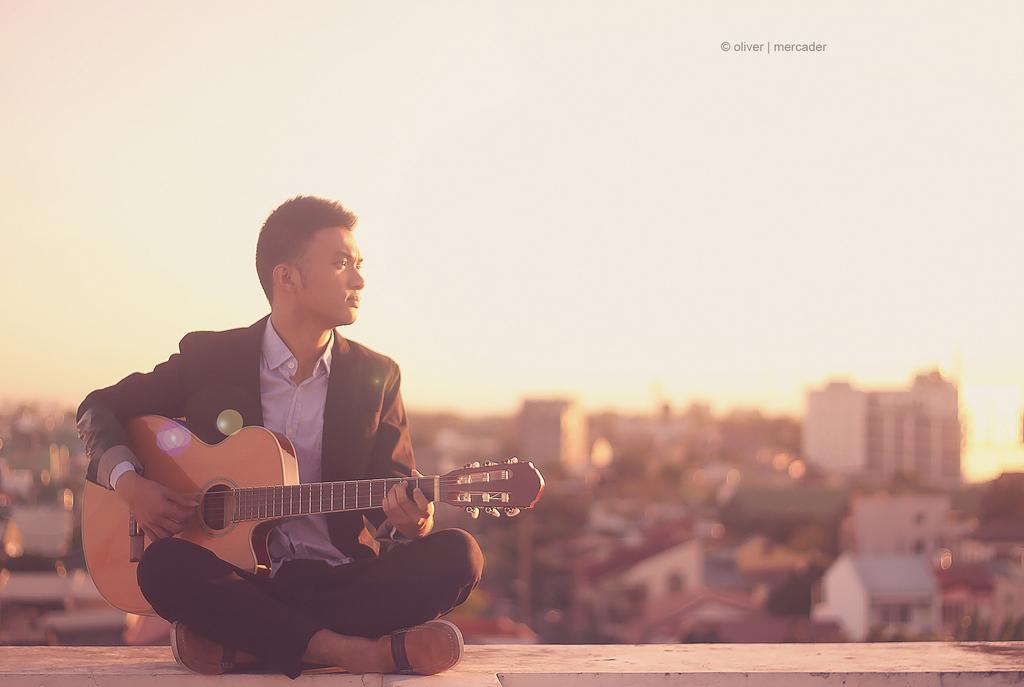What is the man in the image doing? The man is playing a guitar. What is the man wearing in the image? The man is wearing a black jacket and a white shirt. Where is the man sitting in the image? The man is sitting on a wall. What can be seen in the background of the image? There are buildings and the sky visible in the background of the image. How many tickets does the man have in his hand in the image? There is no mention of tickets in the image, so we cannot determine if the man has any tickets. Are there any women present in the image? There is no mention of women in the image, so we cannot determine if there are any women present. 